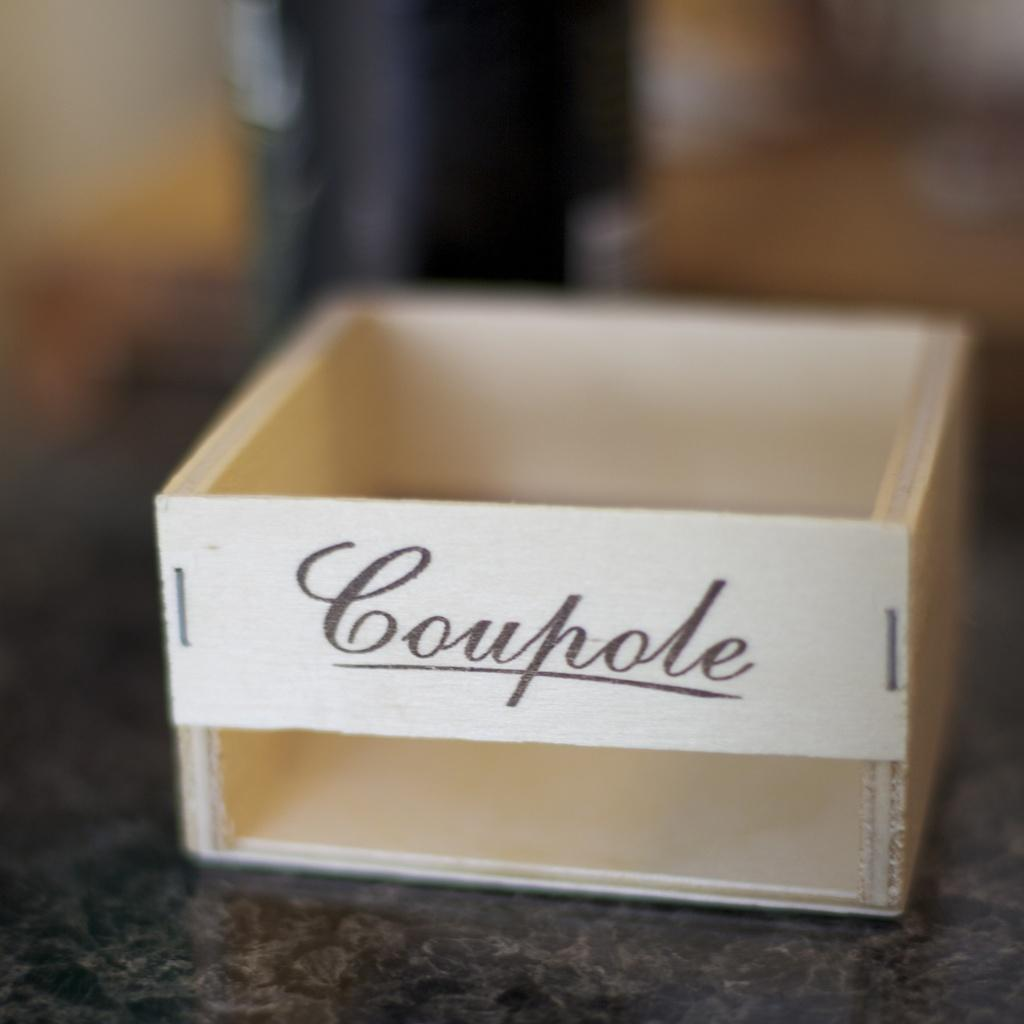<image>
Describe the image concisely. Small wooden box sitting on a table with a word imprinted on the front. 